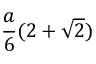Convert formula to latex. <formula><loc_0><loc_0><loc_500><loc_500>{ \frac { a } { 6 } } ( 2 + { \sqrt { 2 } } )</formula> 